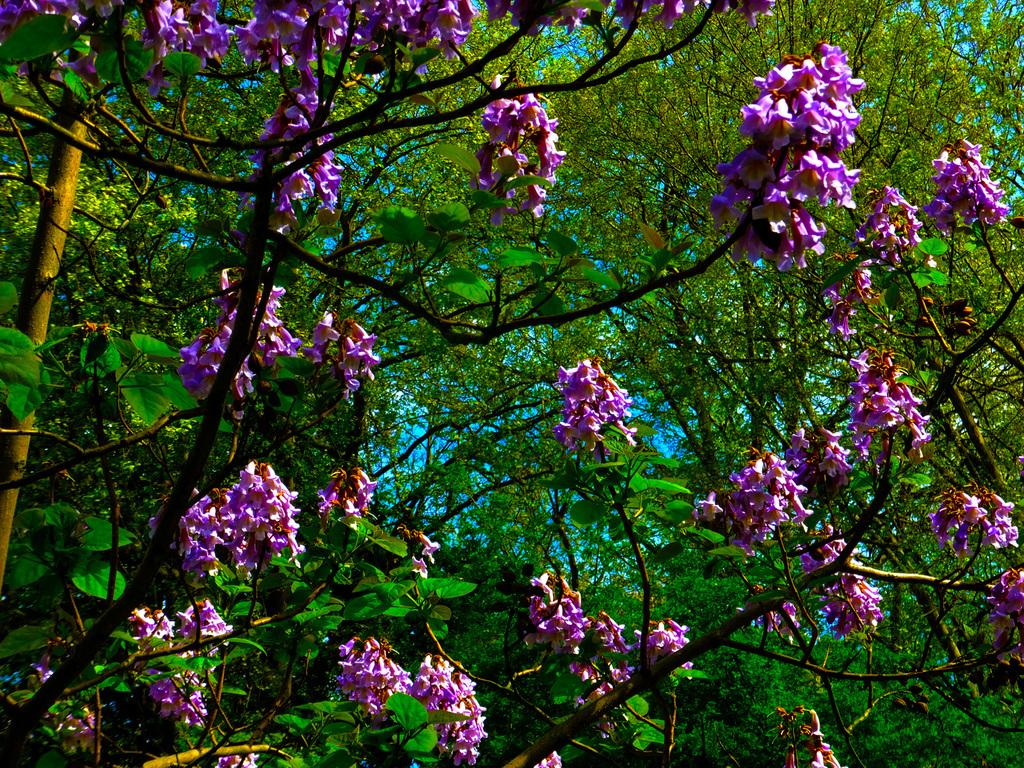What is present in the image? There is a tree in the image. What can be observed about the tree? The tree has flowers. Can you see the tree making a request in the image? There is no indication in the image that the tree is making a request, as trees do not have the ability to make requests. 